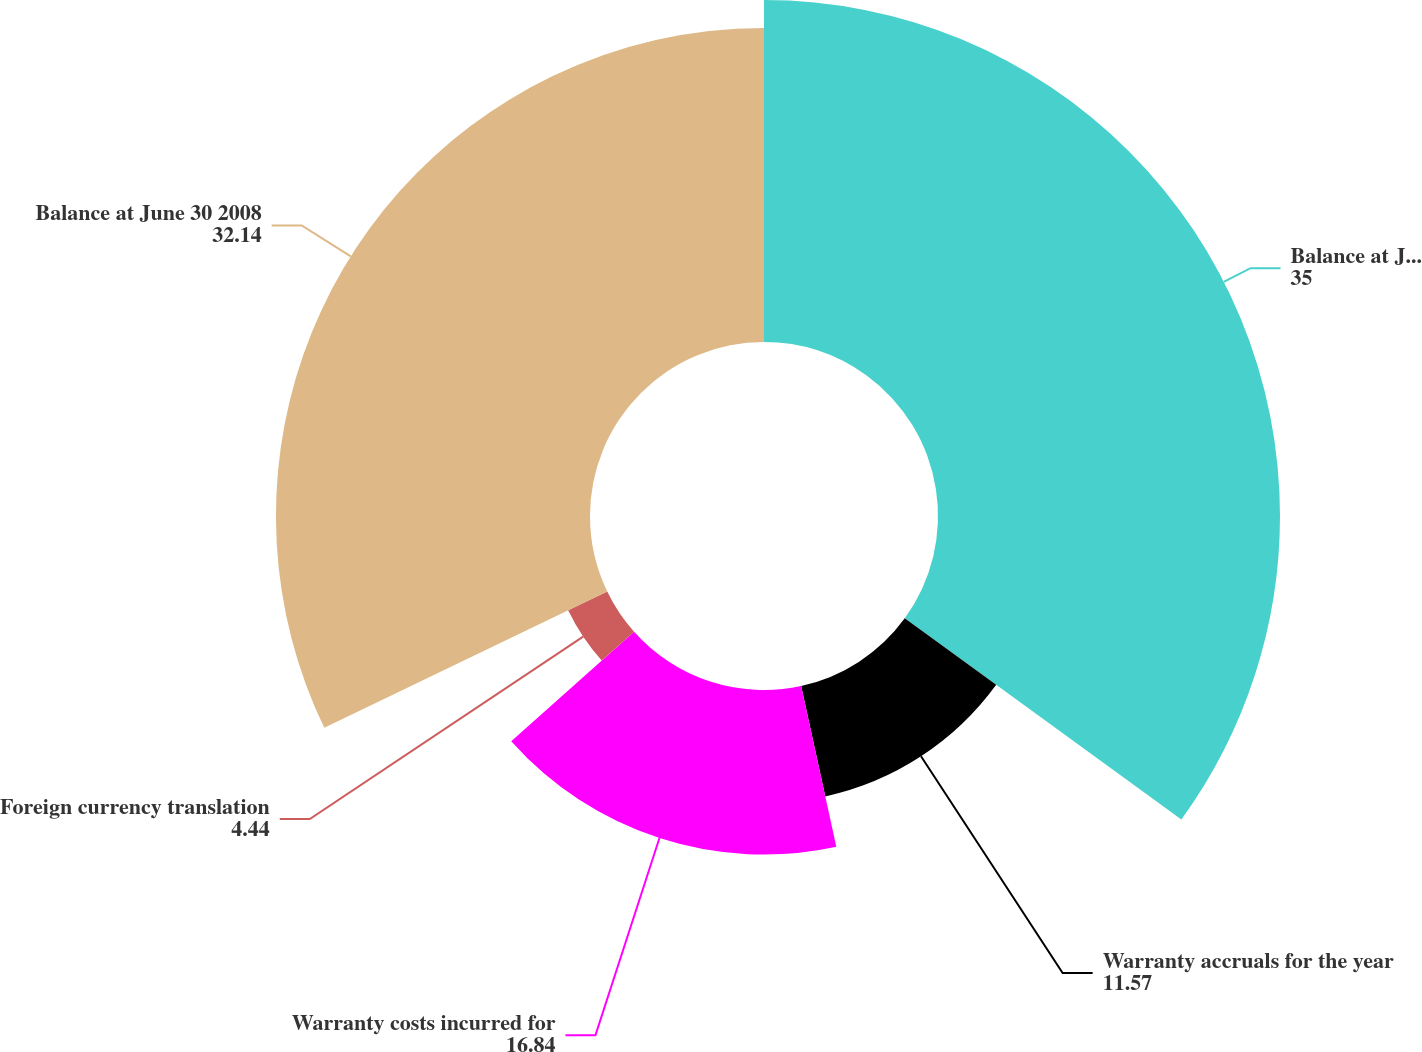Convert chart. <chart><loc_0><loc_0><loc_500><loc_500><pie_chart><fcel>Balance at July 1 2007<fcel>Warranty accruals for the year<fcel>Warranty costs incurred for<fcel>Foreign currency translation<fcel>Balance at June 30 2008<nl><fcel>35.0%<fcel>11.57%<fcel>16.84%<fcel>4.44%<fcel>32.14%<nl></chart> 